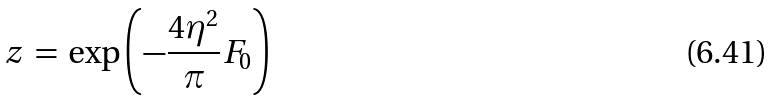<formula> <loc_0><loc_0><loc_500><loc_500>z \, = \, \exp \left ( - \frac { 4 \eta ^ { 2 } } { \pi } F _ { 0 } \right )</formula> 